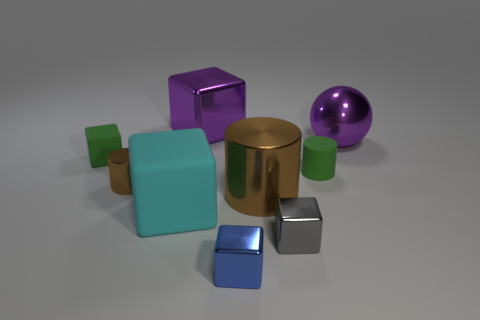The large object that is right of the green matte thing on the right side of the tiny cube that is to the left of the tiny metallic cylinder is what shape?
Ensure brevity in your answer.  Sphere. Are there the same number of small gray metal blocks behind the large brown thing and large cubes behind the green rubber block?
Keep it short and to the point. No. What is the color of the rubber object that is the same size as the sphere?
Your answer should be compact. Cyan. How many small things are purple spheres or metallic cylinders?
Your answer should be compact. 1. The big object that is both to the left of the tiny gray shiny block and behind the matte cylinder is made of what material?
Offer a terse response. Metal. Is the shape of the tiny rubber thing that is right of the tiny gray shiny block the same as the tiny matte object left of the blue metal object?
Your answer should be very brief. No. What shape is the metallic object that is the same color as the small metal cylinder?
Keep it short and to the point. Cylinder. What number of things are either tiny green matte objects that are to the left of the purple block or small green rubber objects?
Your answer should be compact. 2. Is the size of the purple metal block the same as the gray shiny object?
Offer a very short reply. No. There is a tiny metal block behind the small blue cube; what is its color?
Give a very brief answer. Gray. 